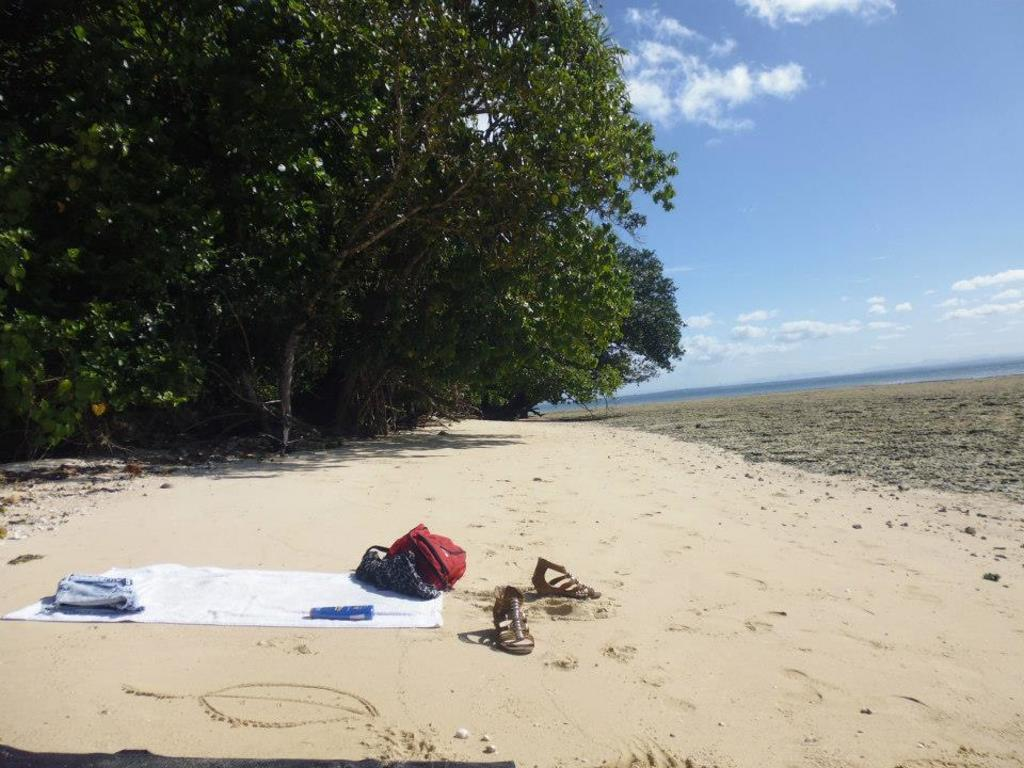What is on the ground in the image? There is a mat in the image. What is located near the mat? There is a bag in the image. What is another object visible in the image? There is a bottle in the image. What type of personal items can be seen in the image? There are clothes and a pair of sandals in the image. What can be seen in the background of the image? There are trees with branches and leaves in the image, and the sky is visible with clouds present. What flavor of ice cream is being played on the mat in the image? There is no ice cream or playing activity present in the image. How does the pair of sandals turn on the mat in the image? The sandals do not turn on the mat in the image; they are stationary. 